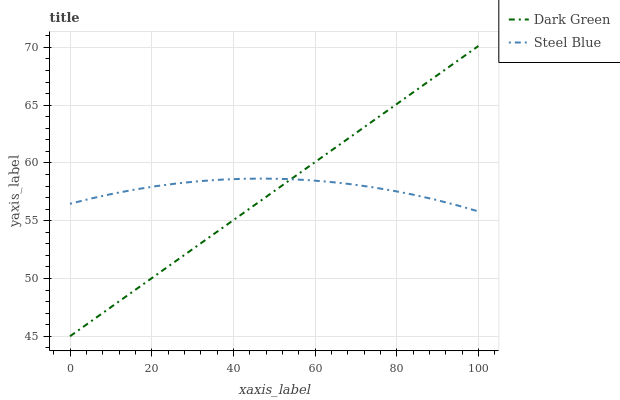Does Dark Green have the minimum area under the curve?
Answer yes or no. Yes. Does Steel Blue have the maximum area under the curve?
Answer yes or no. Yes. Does Dark Green have the maximum area under the curve?
Answer yes or no. No. Is Dark Green the smoothest?
Answer yes or no. Yes. Is Steel Blue the roughest?
Answer yes or no. Yes. Is Dark Green the roughest?
Answer yes or no. No. Does Dark Green have the lowest value?
Answer yes or no. Yes. Does Dark Green have the highest value?
Answer yes or no. Yes. Does Steel Blue intersect Dark Green?
Answer yes or no. Yes. Is Steel Blue less than Dark Green?
Answer yes or no. No. Is Steel Blue greater than Dark Green?
Answer yes or no. No. 